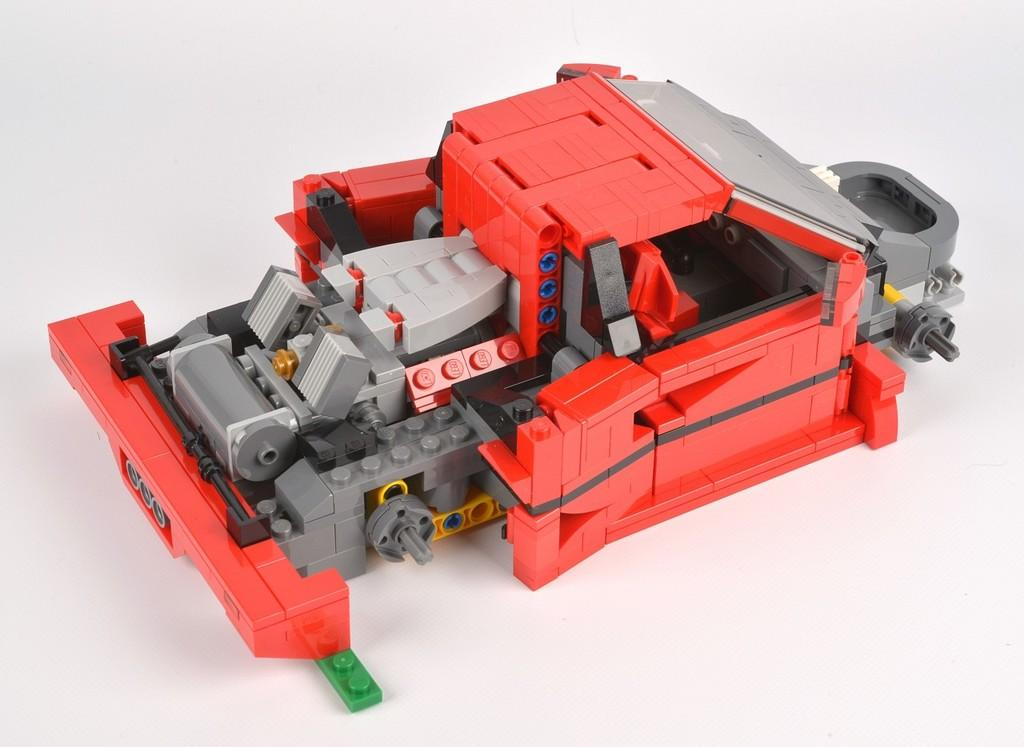What type of toy is present in the image? There is a toy made up of lego in the image. What colors can be seen on the toy? The toy has red, ash, black, yellow, and green colors. What is the color of the background in the image? The background of the image is white. How many dolls are present in the image? There are no dolls present in the image; it features a lego toy. What type of industry is depicted in the image? There is no industry depicted in the image; it features a lego toy against a white background. 